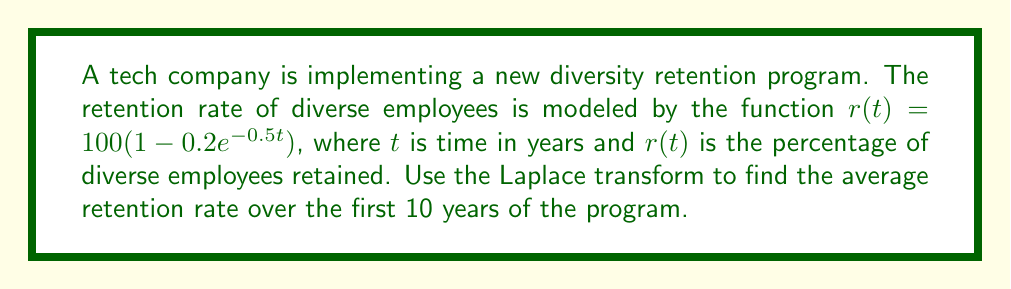Give your solution to this math problem. To solve this problem, we'll follow these steps:

1) First, we need to find the Laplace transform of $r(t)$. Let's call this $R(s)$.

   $R(s) = \mathcal{L}\{r(t)\} = \mathcal{L}\{100(1 - 0.2e^{-0.5t})\}$

2) Using linearity and the known Laplace transform of exponential functions:

   $R(s) = 100\mathcal{L}\{1\} - 20\mathcal{L}\{e^{-0.5t}\}$
   
   $R(s) = \frac{100}{s} - \frac{20}{s+0.5}$

3) To find the average over 10 years, we need to integrate $r(t)$ from 0 to 10 and divide by 10. In the s-domain, this is equivalent to:

   $\frac{1}{10} \cdot \frac{R(s)}{s} \bigg|_{s=0}$

4) Let's substitute our $R(s)$ into this formula:

   $\frac{1}{10} \cdot \frac{1}{s}\left(\frac{100}{s} - \frac{20}{s+0.5}\right) \bigg|_{s=0}$

5) To evaluate this at $s=0$, we need to use L'Hôpital's rule twice:

   $\lim_{s \to 0} \frac{1}{10} \cdot \frac{1}{s}\left(\frac{100}{s} - \frac{20}{s+0.5}\right)$
   
   $= \frac{1}{10} \lim_{s \to 0} \frac{100(s+0.5) - 20s}{s^2(s+0.5)}$
   
   $= \frac{1}{10} \lim_{s \to 0} \frac{100 - 20}{2s(s+0.5) + s^2}$
   
   $= \frac{1}{10} \cdot \frac{80}{0.5} = 16$

Therefore, the average retention rate over the first 10 years is 16%.
Answer: The average retention rate of diverse employees over the first 10 years of the program is 16%. 